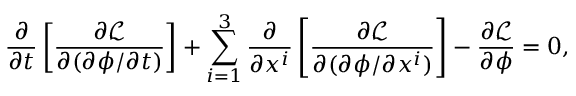Convert formula to latex. <formula><loc_0><loc_0><loc_500><loc_500>{ \frac { \partial } { \partial t } } \left [ { \frac { \partial { \mathcal { L } } } { \partial ( \partial \phi / \partial t ) } } \right ] + \sum _ { i = 1 } ^ { 3 } { \frac { \partial } { \partial x ^ { i } } } \left [ { \frac { \partial { \mathcal { L } } } { \partial ( \partial \phi / \partial x ^ { i } ) } } \right ] - { \frac { \partial { \mathcal { L } } } { \partial \phi } } = 0 ,</formula> 